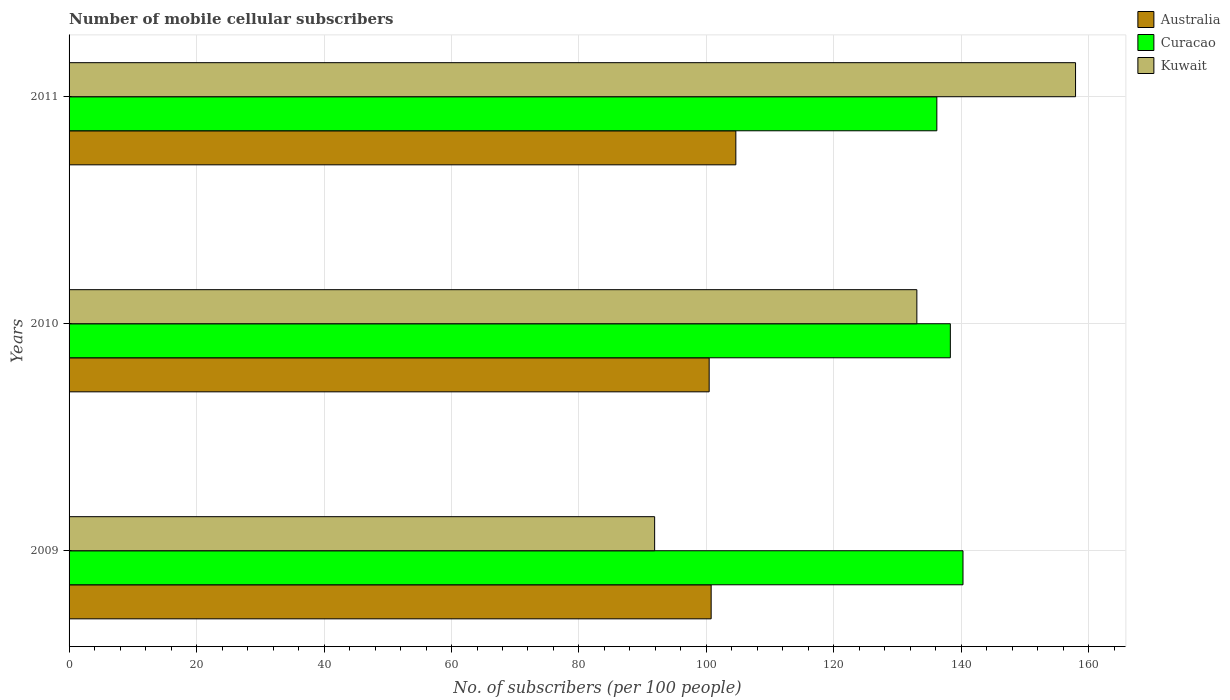Are the number of bars per tick equal to the number of legend labels?
Give a very brief answer. Yes. How many bars are there on the 2nd tick from the top?
Your answer should be very brief. 3. What is the number of mobile cellular subscribers in Australia in 2010?
Your answer should be very brief. 100.43. Across all years, what is the maximum number of mobile cellular subscribers in Curacao?
Give a very brief answer. 140.25. Across all years, what is the minimum number of mobile cellular subscribers in Australia?
Your answer should be compact. 100.43. In which year was the number of mobile cellular subscribers in Kuwait minimum?
Offer a terse response. 2009. What is the total number of mobile cellular subscribers in Curacao in the graph?
Ensure brevity in your answer.  414.66. What is the difference between the number of mobile cellular subscribers in Kuwait in 2009 and that in 2010?
Provide a short and direct response. -41.14. What is the difference between the number of mobile cellular subscribers in Curacao in 2009 and the number of mobile cellular subscribers in Kuwait in 2011?
Your answer should be very brief. -17.66. What is the average number of mobile cellular subscribers in Curacao per year?
Your answer should be very brief. 138.22. In the year 2011, what is the difference between the number of mobile cellular subscribers in Curacao and number of mobile cellular subscribers in Australia?
Give a very brief answer. 31.54. In how many years, is the number of mobile cellular subscribers in Australia greater than 32 ?
Keep it short and to the point. 3. What is the ratio of the number of mobile cellular subscribers in Australia in 2009 to that in 2011?
Keep it short and to the point. 0.96. Is the number of mobile cellular subscribers in Curacao in 2010 less than that in 2011?
Your answer should be compact. No. What is the difference between the highest and the second highest number of mobile cellular subscribers in Australia?
Make the answer very short. 3.87. What is the difference between the highest and the lowest number of mobile cellular subscribers in Australia?
Your answer should be compact. 4.18. In how many years, is the number of mobile cellular subscribers in Kuwait greater than the average number of mobile cellular subscribers in Kuwait taken over all years?
Your answer should be compact. 2. Is the sum of the number of mobile cellular subscribers in Curacao in 2010 and 2011 greater than the maximum number of mobile cellular subscribers in Australia across all years?
Keep it short and to the point. Yes. What does the 2nd bar from the top in 2011 represents?
Your answer should be compact. Curacao. What does the 3rd bar from the bottom in 2010 represents?
Provide a succinct answer. Kuwait. How many bars are there?
Provide a short and direct response. 9. How many years are there in the graph?
Offer a very short reply. 3. What is the difference between two consecutive major ticks on the X-axis?
Ensure brevity in your answer.  20. Does the graph contain any zero values?
Provide a short and direct response. No. Does the graph contain grids?
Give a very brief answer. Yes. What is the title of the graph?
Your answer should be compact. Number of mobile cellular subscribers. What is the label or title of the X-axis?
Your answer should be very brief. No. of subscribers (per 100 people). What is the No. of subscribers (per 100 people) of Australia in 2009?
Keep it short and to the point. 100.74. What is the No. of subscribers (per 100 people) in Curacao in 2009?
Your response must be concise. 140.25. What is the No. of subscribers (per 100 people) of Kuwait in 2009?
Keep it short and to the point. 91.87. What is the No. of subscribers (per 100 people) of Australia in 2010?
Offer a very short reply. 100.43. What is the No. of subscribers (per 100 people) of Curacao in 2010?
Your answer should be compact. 138.27. What is the No. of subscribers (per 100 people) of Kuwait in 2010?
Make the answer very short. 133.01. What is the No. of subscribers (per 100 people) in Australia in 2011?
Provide a short and direct response. 104.61. What is the No. of subscribers (per 100 people) in Curacao in 2011?
Make the answer very short. 136.15. What is the No. of subscribers (per 100 people) in Kuwait in 2011?
Make the answer very short. 157.91. Across all years, what is the maximum No. of subscribers (per 100 people) of Australia?
Provide a short and direct response. 104.61. Across all years, what is the maximum No. of subscribers (per 100 people) in Curacao?
Provide a short and direct response. 140.25. Across all years, what is the maximum No. of subscribers (per 100 people) of Kuwait?
Your answer should be very brief. 157.91. Across all years, what is the minimum No. of subscribers (per 100 people) in Australia?
Give a very brief answer. 100.43. Across all years, what is the minimum No. of subscribers (per 100 people) of Curacao?
Your response must be concise. 136.15. Across all years, what is the minimum No. of subscribers (per 100 people) of Kuwait?
Your answer should be very brief. 91.87. What is the total No. of subscribers (per 100 people) in Australia in the graph?
Your response must be concise. 305.78. What is the total No. of subscribers (per 100 people) in Curacao in the graph?
Offer a terse response. 414.66. What is the total No. of subscribers (per 100 people) of Kuwait in the graph?
Ensure brevity in your answer.  382.79. What is the difference between the No. of subscribers (per 100 people) in Australia in 2009 and that in 2010?
Keep it short and to the point. 0.31. What is the difference between the No. of subscribers (per 100 people) in Curacao in 2009 and that in 2010?
Your answer should be compact. 1.98. What is the difference between the No. of subscribers (per 100 people) of Kuwait in 2009 and that in 2010?
Your answer should be very brief. -41.14. What is the difference between the No. of subscribers (per 100 people) of Australia in 2009 and that in 2011?
Your answer should be very brief. -3.87. What is the difference between the No. of subscribers (per 100 people) of Curacao in 2009 and that in 2011?
Offer a very short reply. 4.1. What is the difference between the No. of subscribers (per 100 people) of Kuwait in 2009 and that in 2011?
Offer a very short reply. -66.04. What is the difference between the No. of subscribers (per 100 people) of Australia in 2010 and that in 2011?
Keep it short and to the point. -4.18. What is the difference between the No. of subscribers (per 100 people) in Curacao in 2010 and that in 2011?
Your response must be concise. 2.12. What is the difference between the No. of subscribers (per 100 people) in Kuwait in 2010 and that in 2011?
Offer a terse response. -24.9. What is the difference between the No. of subscribers (per 100 people) in Australia in 2009 and the No. of subscribers (per 100 people) in Curacao in 2010?
Give a very brief answer. -37.53. What is the difference between the No. of subscribers (per 100 people) of Australia in 2009 and the No. of subscribers (per 100 people) of Kuwait in 2010?
Keep it short and to the point. -32.27. What is the difference between the No. of subscribers (per 100 people) in Curacao in 2009 and the No. of subscribers (per 100 people) in Kuwait in 2010?
Offer a terse response. 7.24. What is the difference between the No. of subscribers (per 100 people) of Australia in 2009 and the No. of subscribers (per 100 people) of Curacao in 2011?
Your answer should be compact. -35.41. What is the difference between the No. of subscribers (per 100 people) in Australia in 2009 and the No. of subscribers (per 100 people) in Kuwait in 2011?
Offer a very short reply. -57.17. What is the difference between the No. of subscribers (per 100 people) in Curacao in 2009 and the No. of subscribers (per 100 people) in Kuwait in 2011?
Offer a very short reply. -17.66. What is the difference between the No. of subscribers (per 100 people) in Australia in 2010 and the No. of subscribers (per 100 people) in Curacao in 2011?
Provide a succinct answer. -35.72. What is the difference between the No. of subscribers (per 100 people) in Australia in 2010 and the No. of subscribers (per 100 people) in Kuwait in 2011?
Your response must be concise. -57.48. What is the difference between the No. of subscribers (per 100 people) of Curacao in 2010 and the No. of subscribers (per 100 people) of Kuwait in 2011?
Provide a succinct answer. -19.64. What is the average No. of subscribers (per 100 people) in Australia per year?
Offer a terse response. 101.93. What is the average No. of subscribers (per 100 people) of Curacao per year?
Your answer should be compact. 138.22. What is the average No. of subscribers (per 100 people) of Kuwait per year?
Keep it short and to the point. 127.6. In the year 2009, what is the difference between the No. of subscribers (per 100 people) in Australia and No. of subscribers (per 100 people) in Curacao?
Your response must be concise. -39.51. In the year 2009, what is the difference between the No. of subscribers (per 100 people) of Australia and No. of subscribers (per 100 people) of Kuwait?
Offer a very short reply. 8.87. In the year 2009, what is the difference between the No. of subscribers (per 100 people) in Curacao and No. of subscribers (per 100 people) in Kuwait?
Provide a succinct answer. 48.38. In the year 2010, what is the difference between the No. of subscribers (per 100 people) of Australia and No. of subscribers (per 100 people) of Curacao?
Ensure brevity in your answer.  -37.84. In the year 2010, what is the difference between the No. of subscribers (per 100 people) in Australia and No. of subscribers (per 100 people) in Kuwait?
Make the answer very short. -32.59. In the year 2010, what is the difference between the No. of subscribers (per 100 people) of Curacao and No. of subscribers (per 100 people) of Kuwait?
Your answer should be compact. 5.25. In the year 2011, what is the difference between the No. of subscribers (per 100 people) in Australia and No. of subscribers (per 100 people) in Curacao?
Your answer should be compact. -31.54. In the year 2011, what is the difference between the No. of subscribers (per 100 people) of Australia and No. of subscribers (per 100 people) of Kuwait?
Keep it short and to the point. -53.3. In the year 2011, what is the difference between the No. of subscribers (per 100 people) of Curacao and No. of subscribers (per 100 people) of Kuwait?
Offer a very short reply. -21.76. What is the ratio of the No. of subscribers (per 100 people) of Australia in 2009 to that in 2010?
Provide a short and direct response. 1. What is the ratio of the No. of subscribers (per 100 people) in Curacao in 2009 to that in 2010?
Make the answer very short. 1.01. What is the ratio of the No. of subscribers (per 100 people) in Kuwait in 2009 to that in 2010?
Keep it short and to the point. 0.69. What is the ratio of the No. of subscribers (per 100 people) of Australia in 2009 to that in 2011?
Give a very brief answer. 0.96. What is the ratio of the No. of subscribers (per 100 people) in Curacao in 2009 to that in 2011?
Ensure brevity in your answer.  1.03. What is the ratio of the No. of subscribers (per 100 people) of Kuwait in 2009 to that in 2011?
Offer a very short reply. 0.58. What is the ratio of the No. of subscribers (per 100 people) in Australia in 2010 to that in 2011?
Provide a short and direct response. 0.96. What is the ratio of the No. of subscribers (per 100 people) of Curacao in 2010 to that in 2011?
Ensure brevity in your answer.  1.02. What is the ratio of the No. of subscribers (per 100 people) in Kuwait in 2010 to that in 2011?
Your answer should be compact. 0.84. What is the difference between the highest and the second highest No. of subscribers (per 100 people) of Australia?
Offer a terse response. 3.87. What is the difference between the highest and the second highest No. of subscribers (per 100 people) of Curacao?
Give a very brief answer. 1.98. What is the difference between the highest and the second highest No. of subscribers (per 100 people) in Kuwait?
Provide a short and direct response. 24.9. What is the difference between the highest and the lowest No. of subscribers (per 100 people) of Australia?
Your answer should be very brief. 4.18. What is the difference between the highest and the lowest No. of subscribers (per 100 people) of Curacao?
Keep it short and to the point. 4.1. What is the difference between the highest and the lowest No. of subscribers (per 100 people) of Kuwait?
Your answer should be compact. 66.04. 